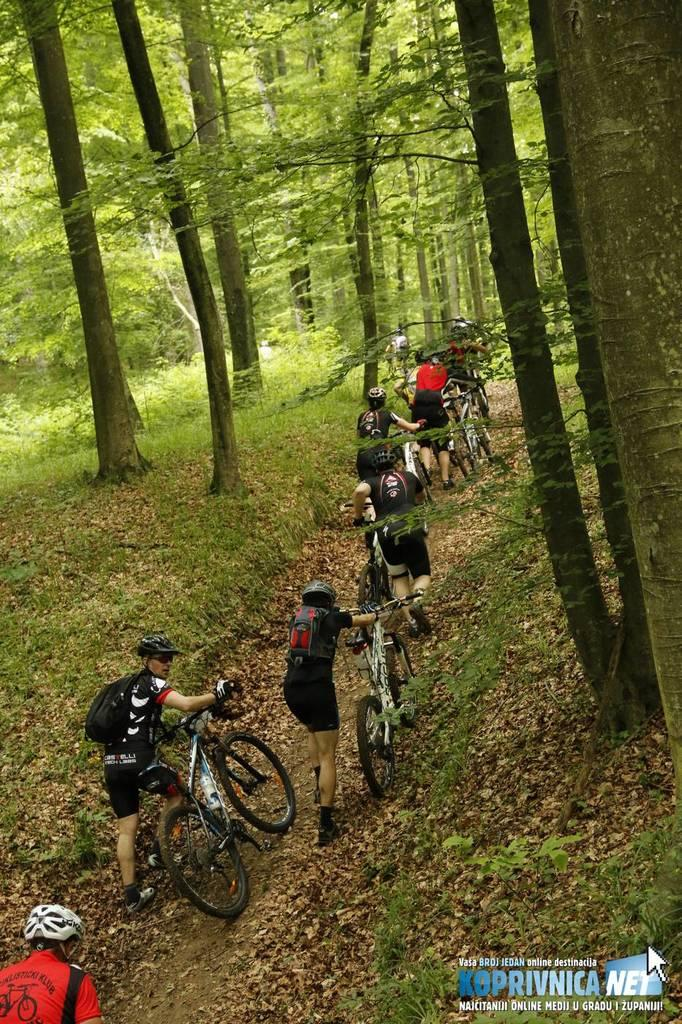What type of vehicles are in the image? There are bicycles in the image. What are the people doing with the bicycles? People are holding the bicycles in the image. What accessories are the people wearing? The people are wearing bags and helmets in the image. What can be seen in the background of the image? There are trees visible at the top of the image. What type of insurance policy is being discussed by the people in the image? There is no indication in the image that the people are discussing any insurance policies. 